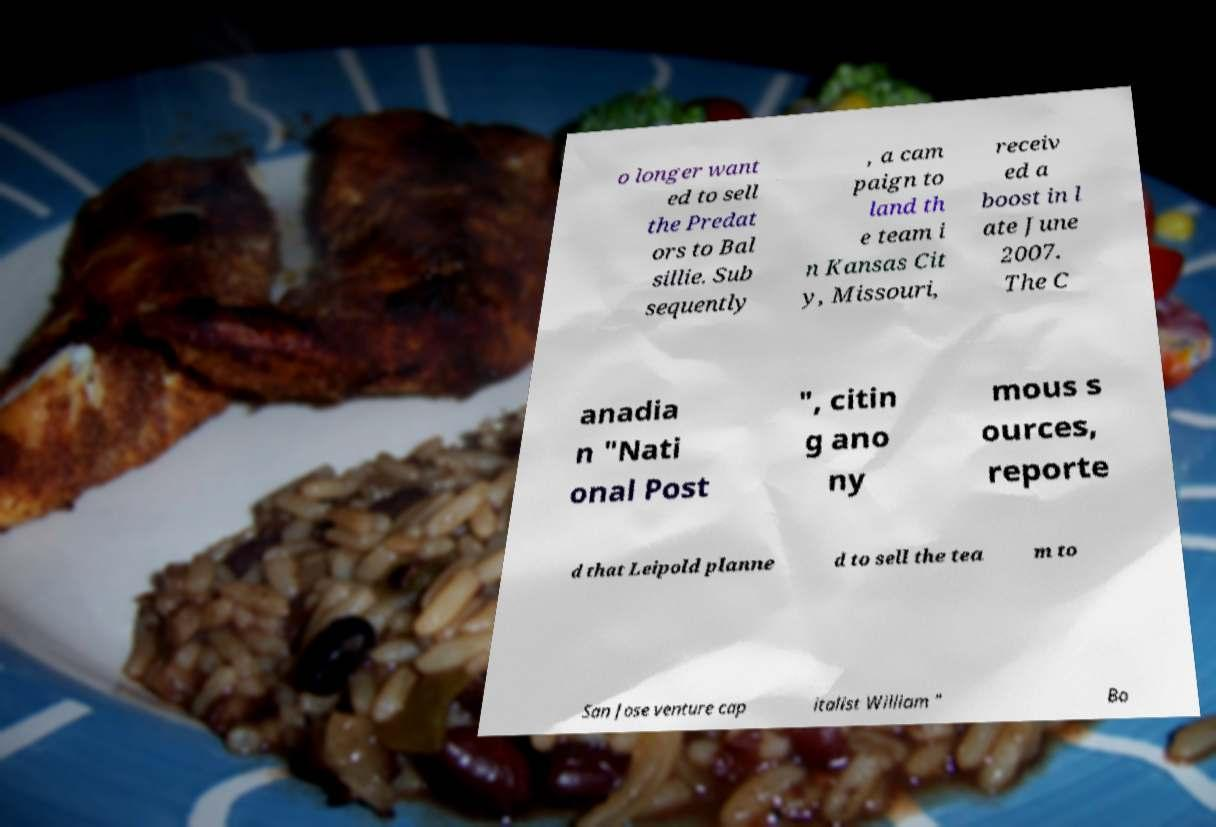For documentation purposes, I need the text within this image transcribed. Could you provide that? o longer want ed to sell the Predat ors to Bal sillie. Sub sequently , a cam paign to land th e team i n Kansas Cit y, Missouri, receiv ed a boost in l ate June 2007. The C anadia n "Nati onal Post ", citin g ano ny mous s ources, reporte d that Leipold planne d to sell the tea m to San Jose venture cap italist William " Bo 